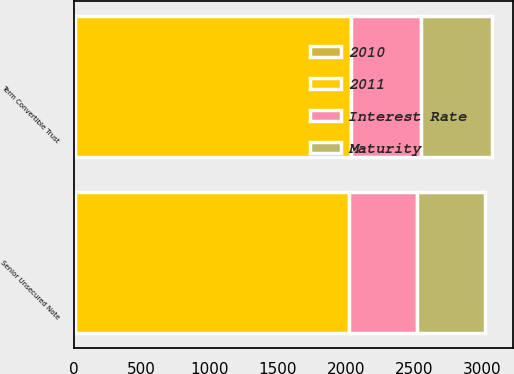Convert chart to OTSL. <chart><loc_0><loc_0><loc_500><loc_500><stacked_bar_chart><ecel><fcel>Senior Unsecured Note<fcel>Term Convertible Trust<nl><fcel>2010<fcel>7.75<fcel>6.75<nl><fcel>2011<fcel>2014<fcel>2029<nl><fcel>Maturity<fcel>500<fcel>517<nl><fcel>Interest Rate<fcel>500<fcel>517<nl></chart> 